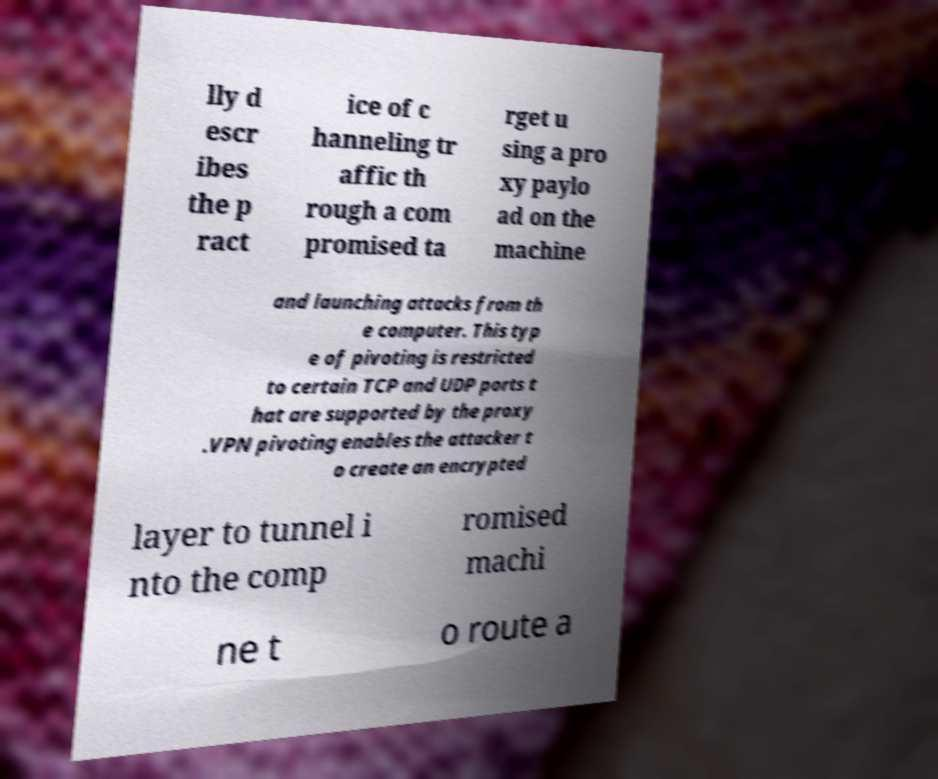I need the written content from this picture converted into text. Can you do that? lly d escr ibes the p ract ice of c hanneling tr affic th rough a com promised ta rget u sing a pro xy paylo ad on the machine and launching attacks from th e computer. This typ e of pivoting is restricted to certain TCP and UDP ports t hat are supported by the proxy .VPN pivoting enables the attacker t o create an encrypted layer to tunnel i nto the comp romised machi ne t o route a 